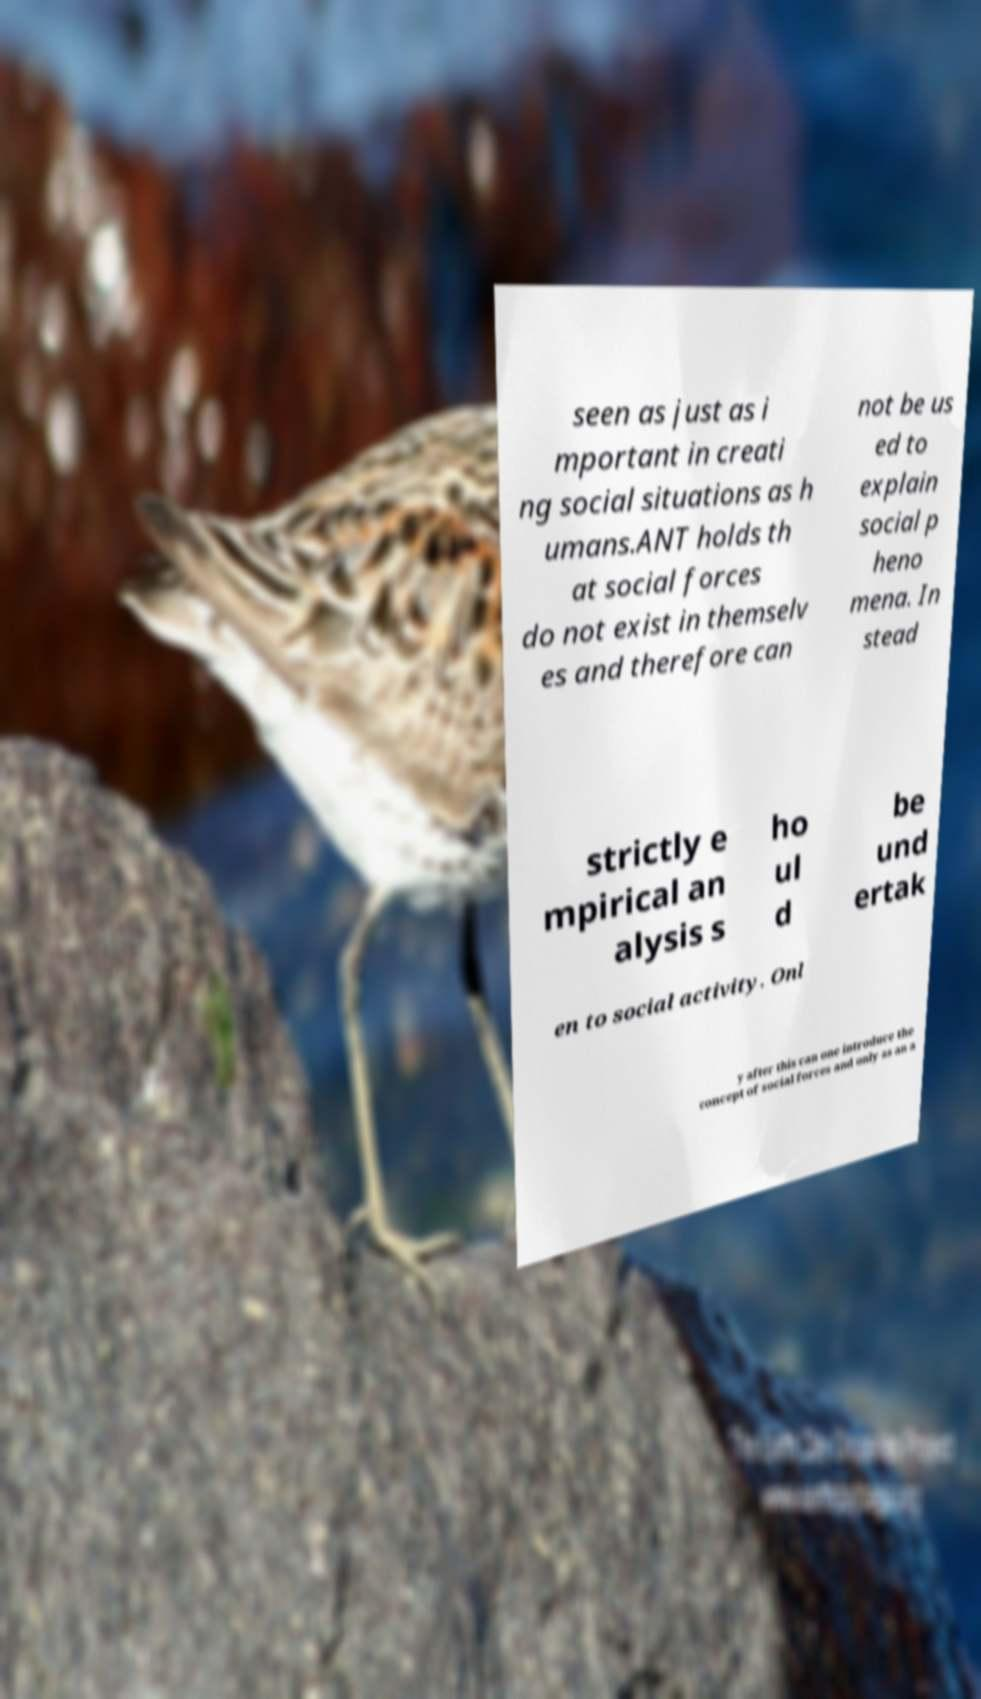Please identify and transcribe the text found in this image. seen as just as i mportant in creati ng social situations as h umans.ANT holds th at social forces do not exist in themselv es and therefore can not be us ed to explain social p heno mena. In stead strictly e mpirical an alysis s ho ul d be und ertak en to social activity. Onl y after this can one introduce the concept of social forces and only as an a 